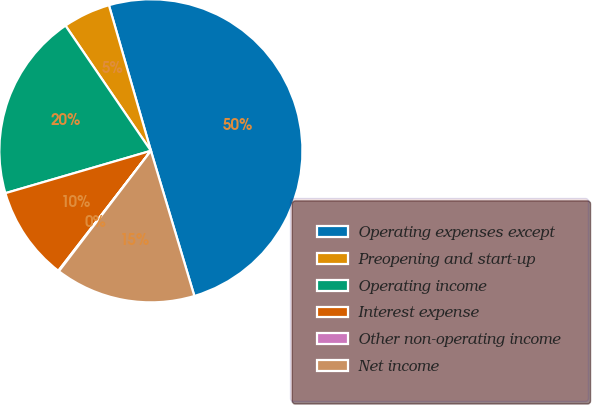<chart> <loc_0><loc_0><loc_500><loc_500><pie_chart><fcel>Operating expenses except<fcel>Preopening and start-up<fcel>Operating income<fcel>Interest expense<fcel>Other non-operating income<fcel>Net income<nl><fcel>49.84%<fcel>5.06%<fcel>19.98%<fcel>10.03%<fcel>0.08%<fcel>15.01%<nl></chart> 